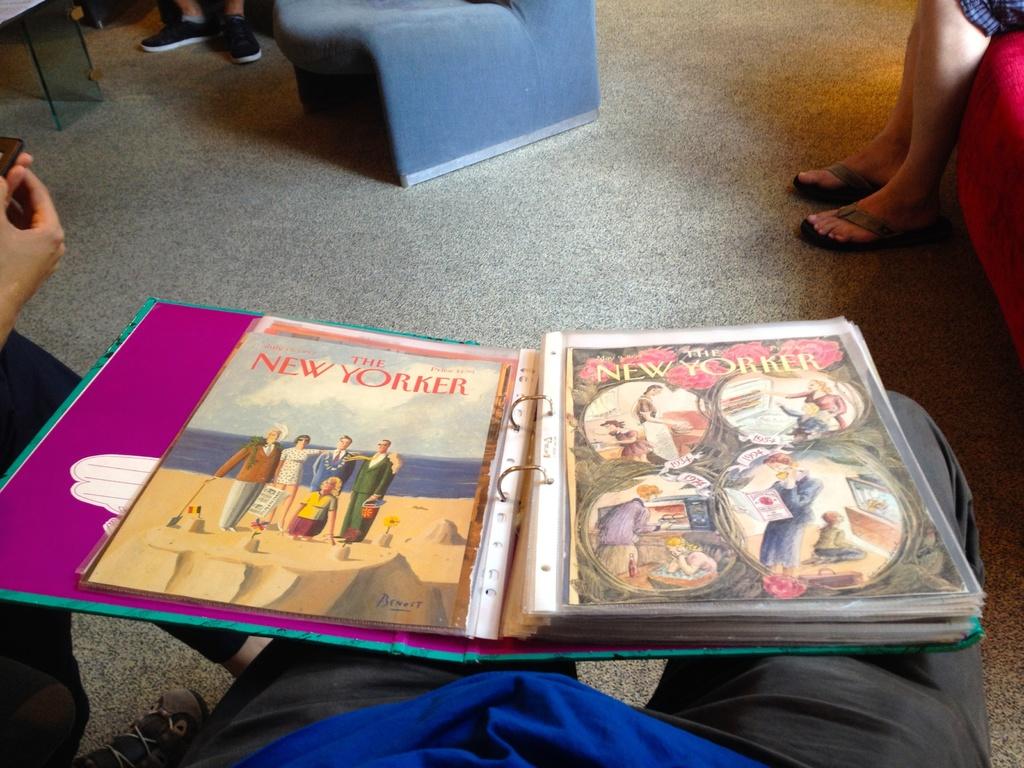What is this famous new york-based magazine?
Make the answer very short. The new yorker. 